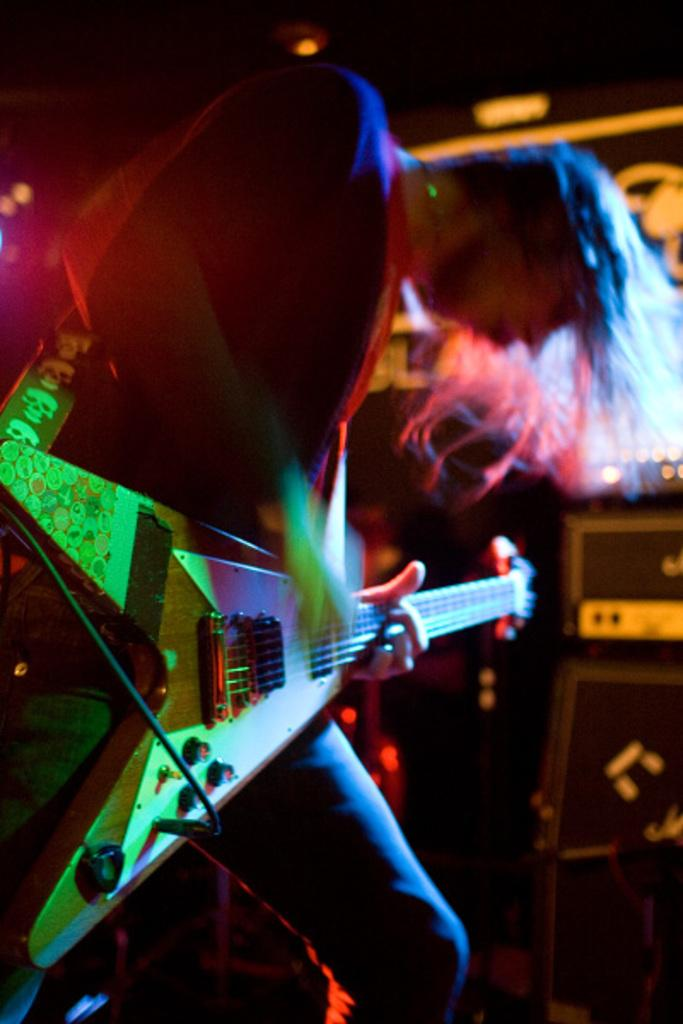What is the man in the image doing? The man is playing the guitar. What type of clothing is the man wearing on his upper body? The man is wearing a coat. What type of clothing is the man wearing on his lower body? The man is wearing trousers. What type of apparatus is the man using to put out a fire in the image? There is no apparatus or fire present in the image; the man is playing the guitar. 